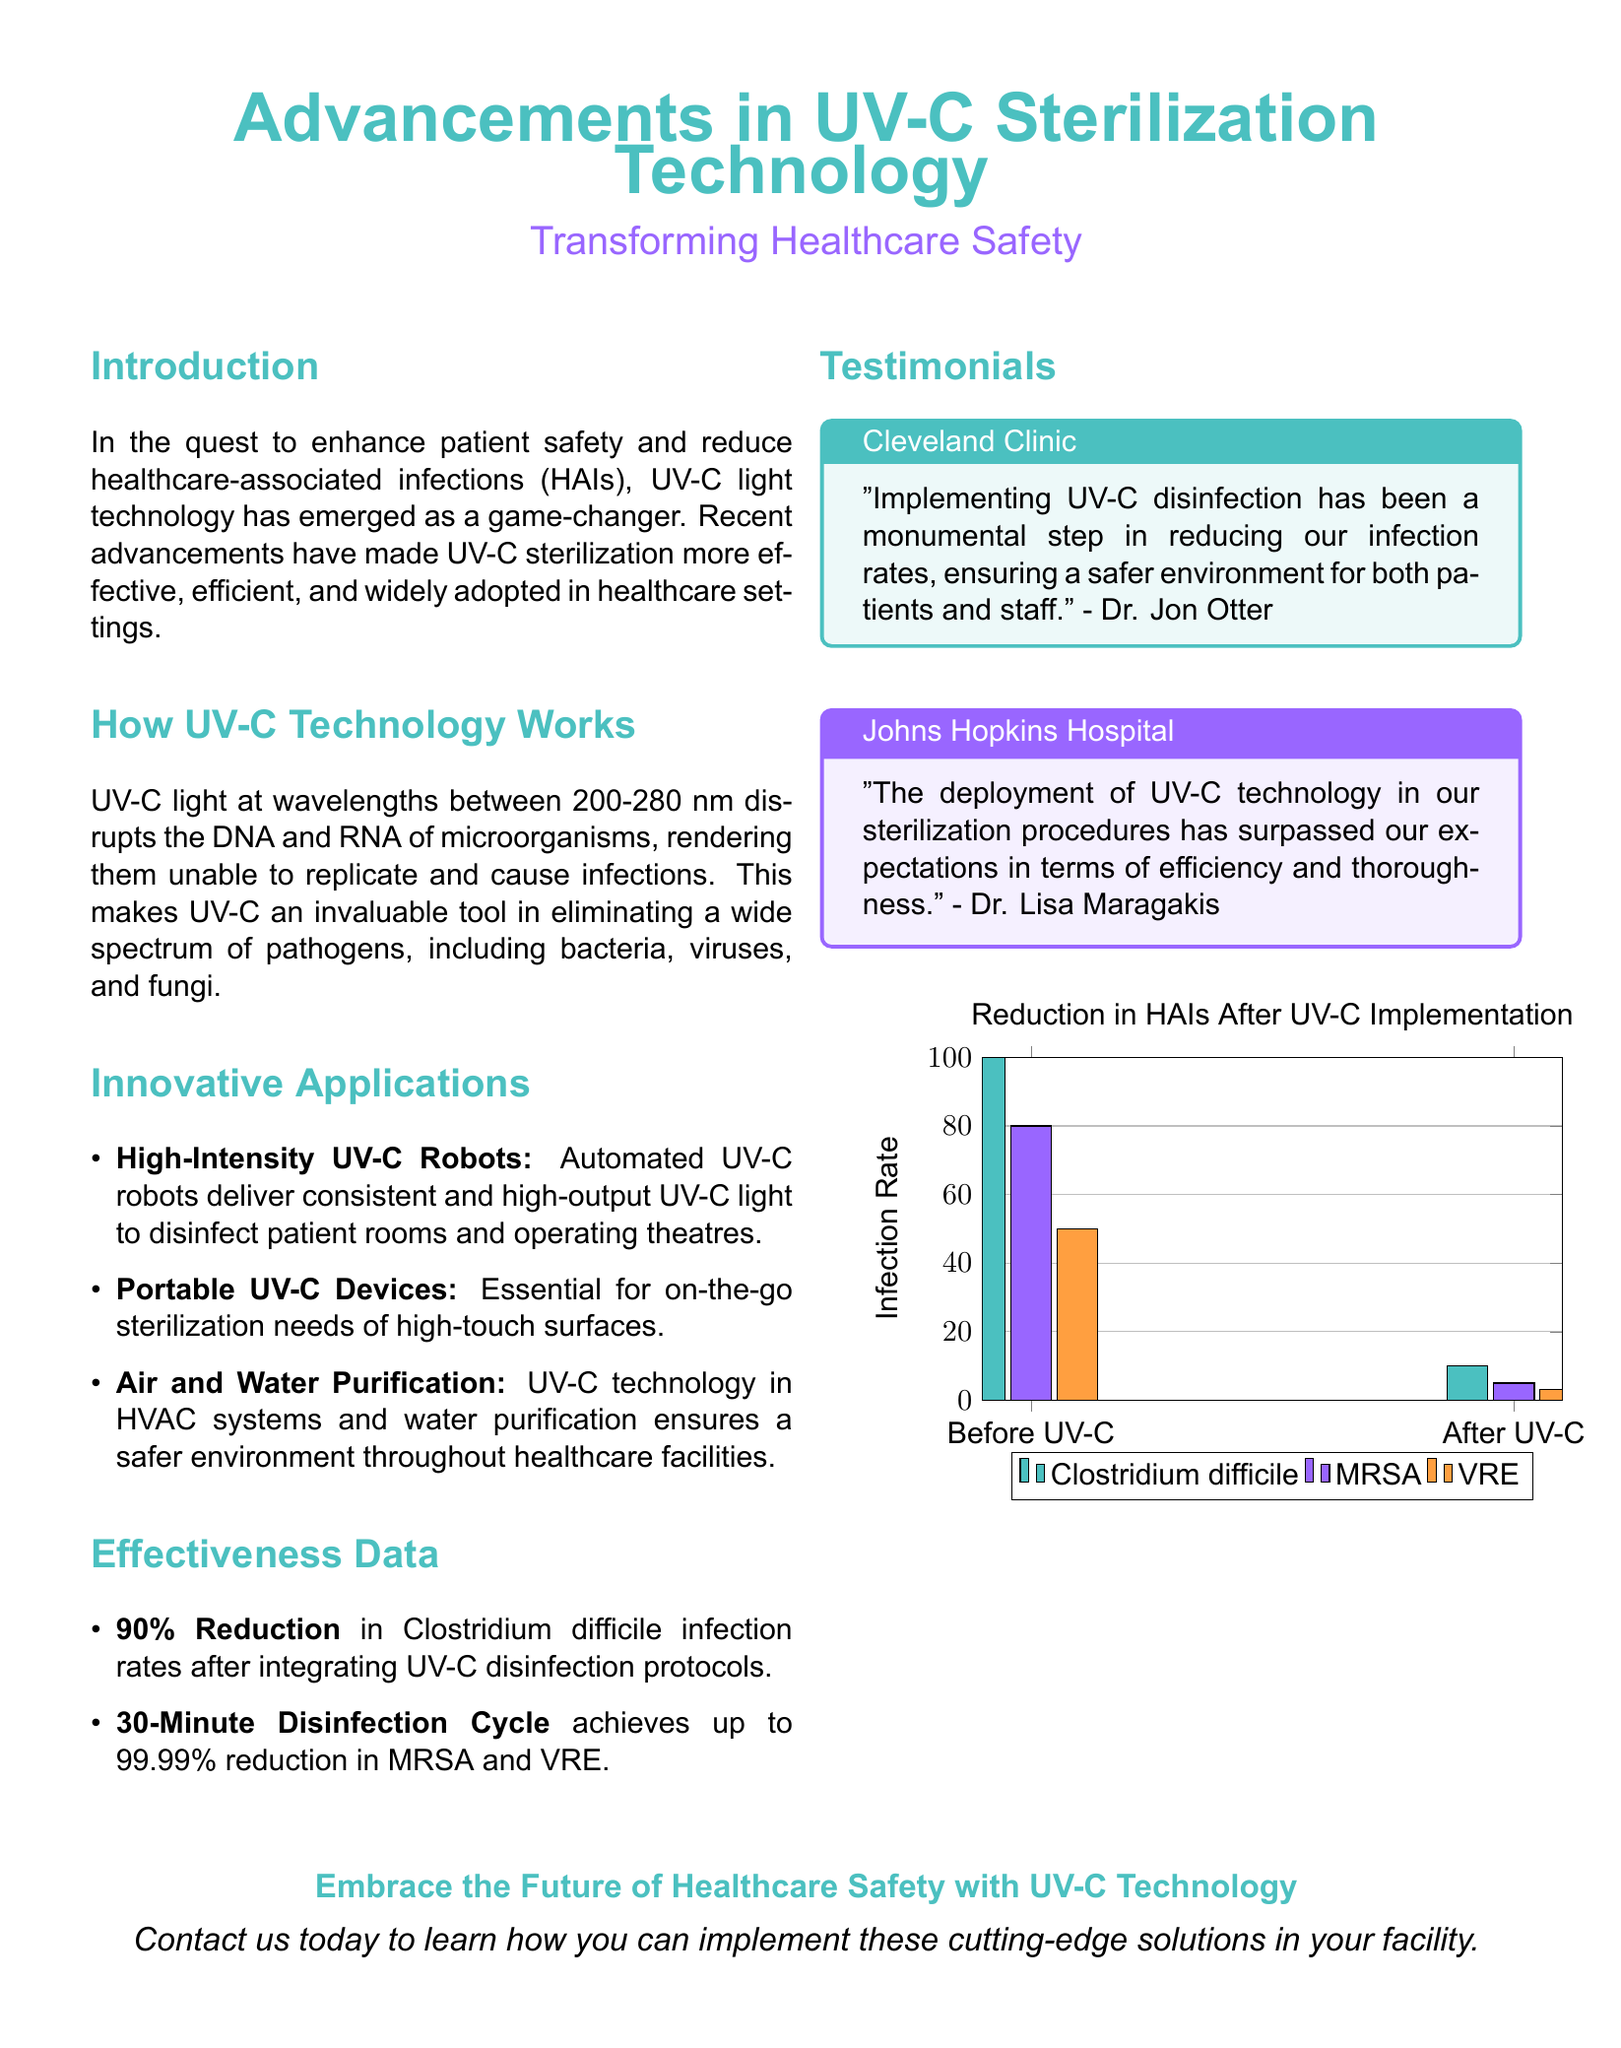what is the wavelength range of UV-C light? The document states that UV-C light operates at wavelengths between 200-280 nm.
Answer: 200-280 nm what percentage reduction in Clostridium difficile infection rates was reported? The document mentions a 90% reduction in Clostridium difficile infection rates after integrating UV-C disinfection protocols.
Answer: 90% how long does the disinfection cycle take to achieve up to 99.99% reduction in MRSA and VRE? The document specifies that a 30-minute disinfection cycle achieves this reduction.
Answer: 30 minutes which hospital is quoted as saying UV-C disinfection was a monumental step in safety? According to the document, Cleveland Clinic's Dr. Jon Otter gave this testimonial.
Answer: Cleveland Clinic what types of pathogens does UV-C technology eliminate? The document indicates that UV-C is effective against bacteria, viruses, and fungi.
Answer: bacteria, viruses, and fungi what is the title of the visual data presented in the document? The title of the visual data is "Reduction in HAIs After UV-C Implementation."
Answer: Reduction in HAIs After UV-C Implementation which organization had doctors that expressed high efficiency and thoroughness in their sterilization procedures? The document cites Johns Hopkins Hospital in this context.
Answer: Johns Hopkins Hospital what is one of the innovative applications of UV-C technology mentioned? There are several applications given, such as High-Intensity UV-C Robots.
Answer: High-Intensity UV-C Robots 